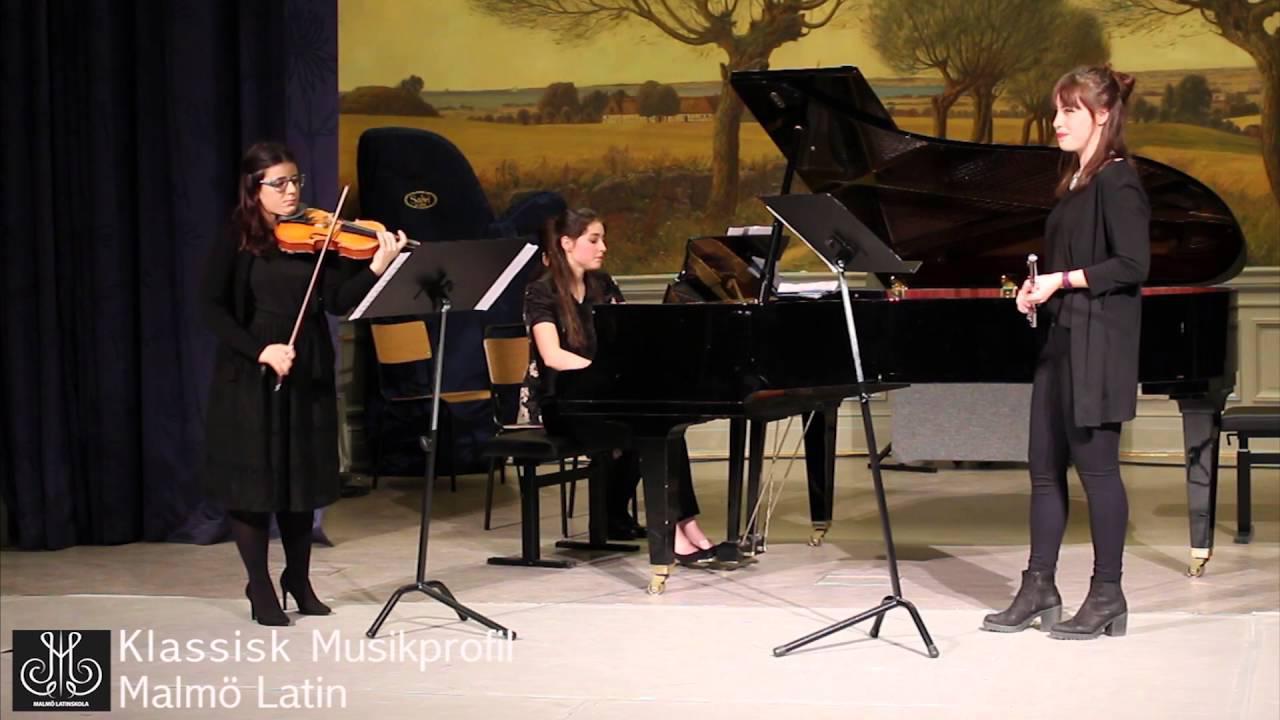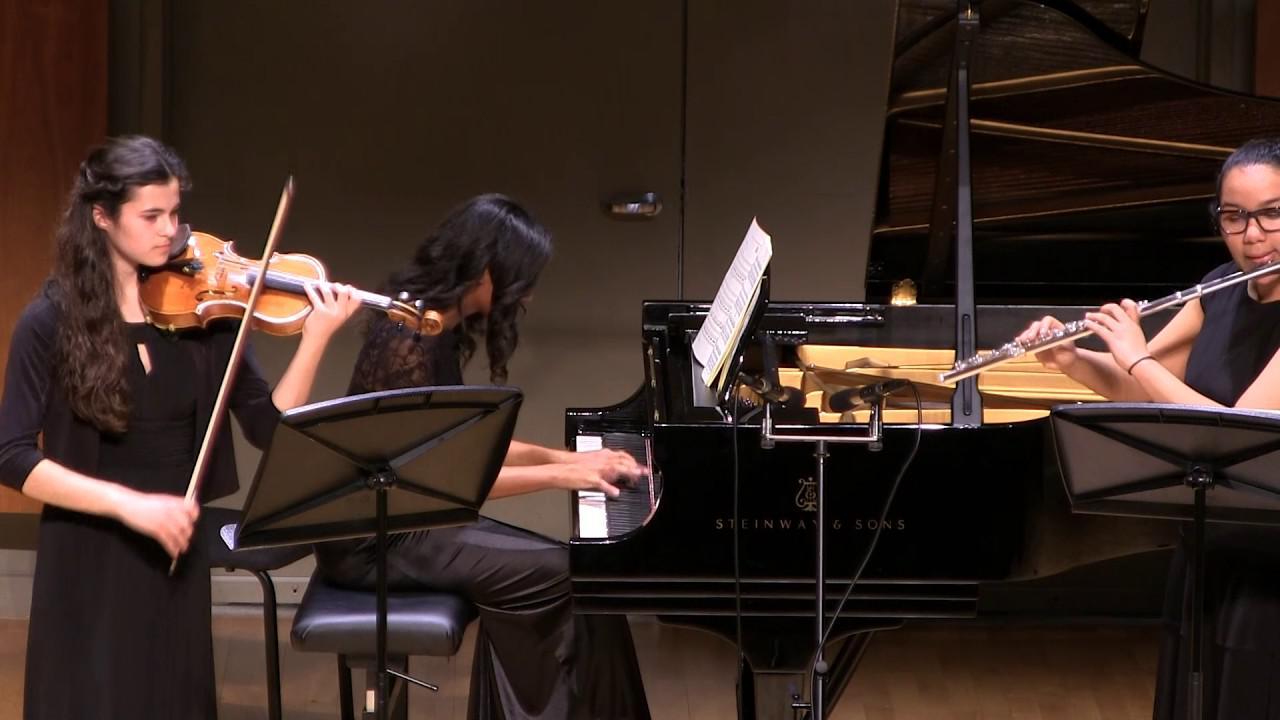The first image is the image on the left, the second image is the image on the right. Assess this claim about the two images: "There are exactly six musicians playing instruments, three in each image.". Correct or not? Answer yes or no. Yes. The first image is the image on the left, the second image is the image on the right. For the images shown, is this caption "Two girls are positioned to the right of a violinist while holding a flute to their mouth." true? Answer yes or no. No. 